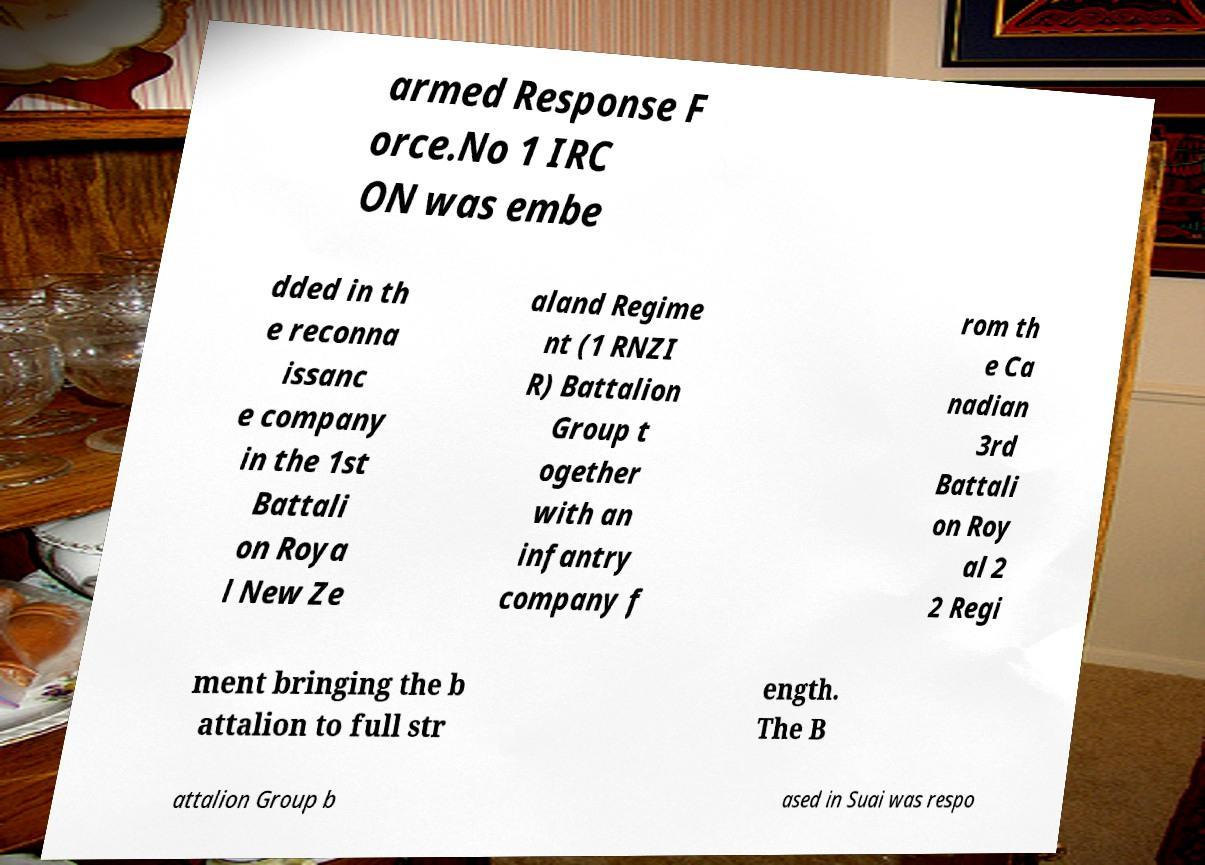Please identify and transcribe the text found in this image. armed Response F orce.No 1 IRC ON was embe dded in th e reconna issanc e company in the 1st Battali on Roya l New Ze aland Regime nt (1 RNZI R) Battalion Group t ogether with an infantry company f rom th e Ca nadian 3rd Battali on Roy al 2 2 Regi ment bringing the b attalion to full str ength. The B attalion Group b ased in Suai was respo 